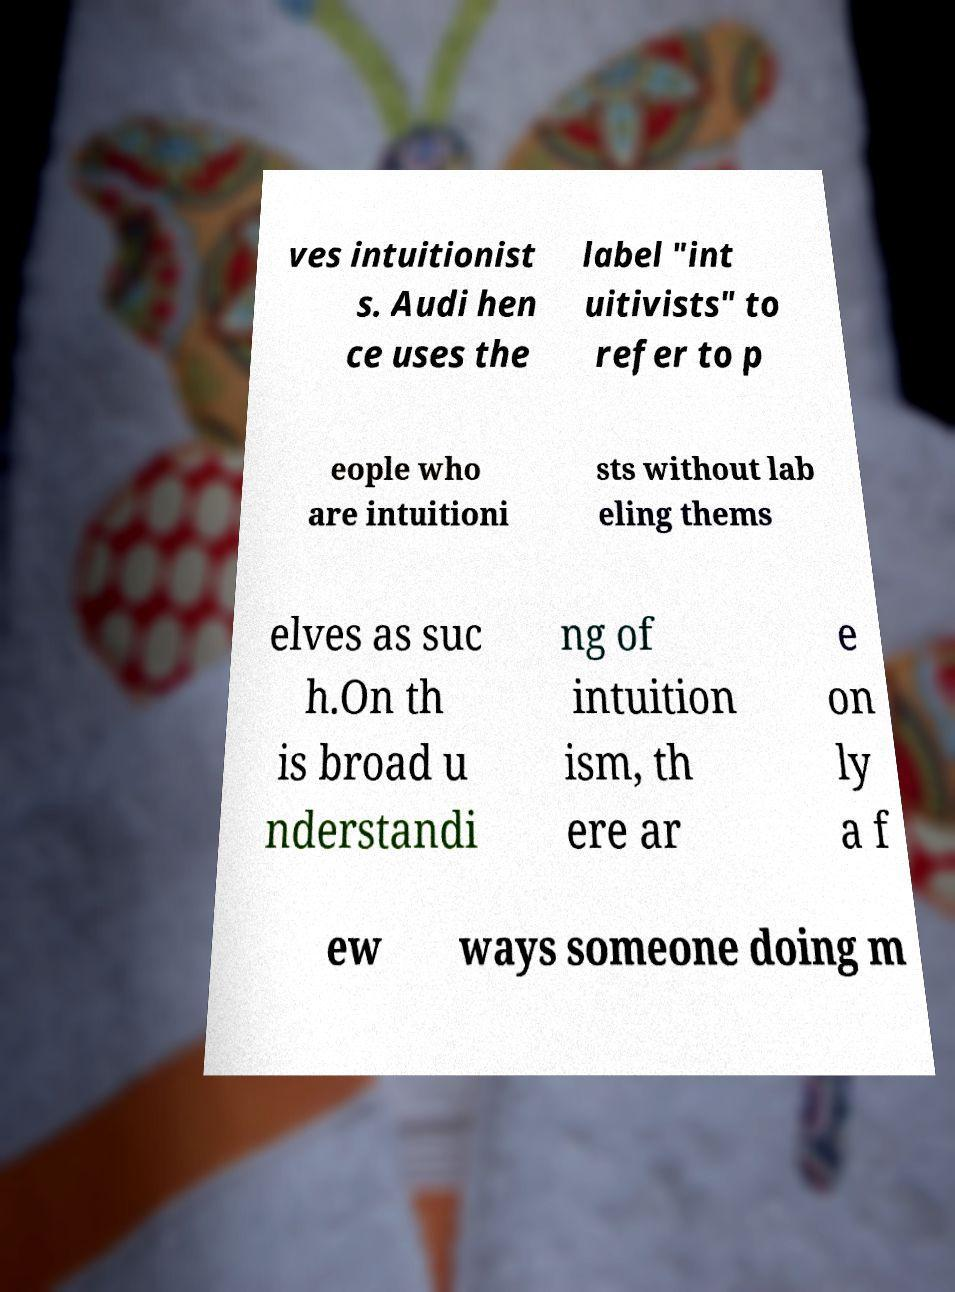Could you assist in decoding the text presented in this image and type it out clearly? ves intuitionist s. Audi hen ce uses the label "int uitivists" to refer to p eople who are intuitioni sts without lab eling thems elves as suc h.On th is broad u nderstandi ng of intuition ism, th ere ar e on ly a f ew ways someone doing m 